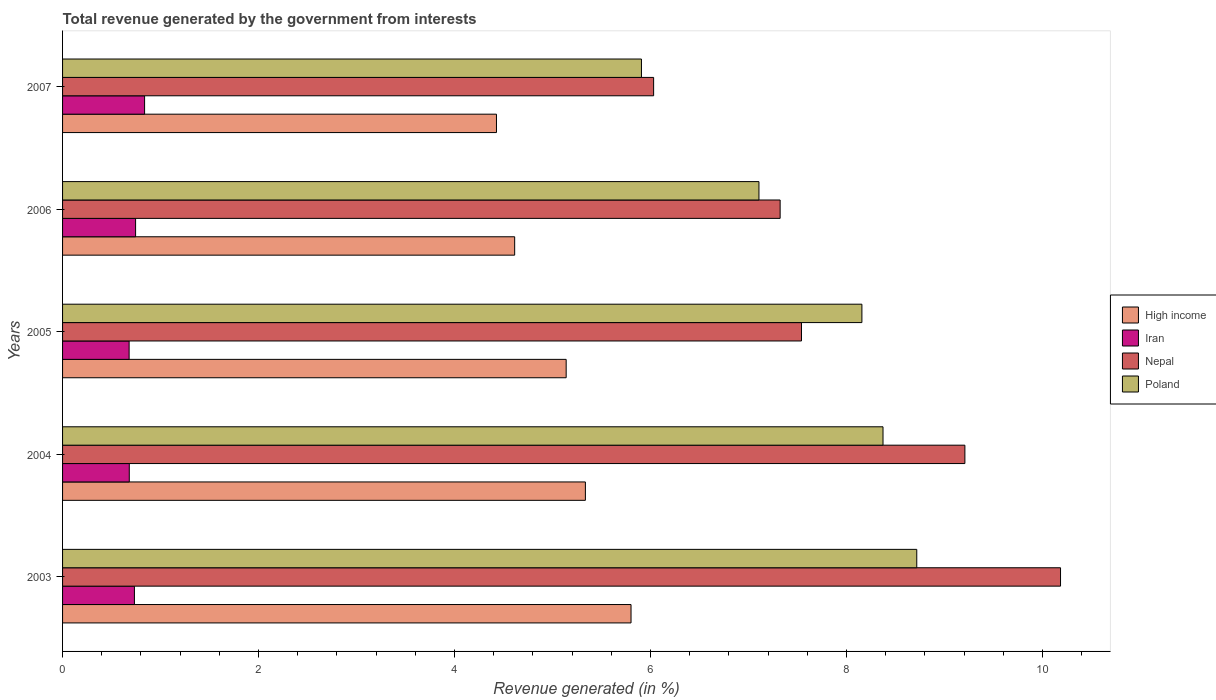How many different coloured bars are there?
Provide a succinct answer. 4. How many groups of bars are there?
Offer a very short reply. 5. Are the number of bars per tick equal to the number of legend labels?
Offer a very short reply. Yes. Are the number of bars on each tick of the Y-axis equal?
Your response must be concise. Yes. How many bars are there on the 3rd tick from the bottom?
Offer a terse response. 4. What is the label of the 4th group of bars from the top?
Offer a terse response. 2004. What is the total revenue generated in High income in 2005?
Your response must be concise. 5.14. Across all years, what is the maximum total revenue generated in Nepal?
Your response must be concise. 10.18. Across all years, what is the minimum total revenue generated in Nepal?
Provide a short and direct response. 6.03. What is the total total revenue generated in High income in the graph?
Make the answer very short. 25.32. What is the difference between the total revenue generated in Iran in 2003 and that in 2007?
Make the answer very short. -0.1. What is the difference between the total revenue generated in Nepal in 2007 and the total revenue generated in Iran in 2003?
Provide a short and direct response. 5.3. What is the average total revenue generated in High income per year?
Your response must be concise. 5.06. In the year 2005, what is the difference between the total revenue generated in Iran and total revenue generated in Poland?
Offer a terse response. -7.48. What is the ratio of the total revenue generated in Nepal in 2005 to that in 2006?
Your answer should be very brief. 1.03. Is the total revenue generated in Nepal in 2003 less than that in 2006?
Keep it short and to the point. No. Is the difference between the total revenue generated in Iran in 2005 and 2006 greater than the difference between the total revenue generated in Poland in 2005 and 2006?
Provide a succinct answer. No. What is the difference between the highest and the second highest total revenue generated in High income?
Keep it short and to the point. 0.47. What is the difference between the highest and the lowest total revenue generated in Nepal?
Keep it short and to the point. 4.15. Is the sum of the total revenue generated in Iran in 2004 and 2005 greater than the maximum total revenue generated in High income across all years?
Your response must be concise. No. What does the 4th bar from the top in 2005 represents?
Your answer should be very brief. High income. What does the 3rd bar from the bottom in 2007 represents?
Provide a succinct answer. Nepal. Is it the case that in every year, the sum of the total revenue generated in Poland and total revenue generated in Iran is greater than the total revenue generated in Nepal?
Offer a very short reply. No. How many bars are there?
Make the answer very short. 20. Are all the bars in the graph horizontal?
Provide a short and direct response. Yes. Does the graph contain grids?
Your answer should be compact. No. Where does the legend appear in the graph?
Make the answer very short. Center right. How are the legend labels stacked?
Ensure brevity in your answer.  Vertical. What is the title of the graph?
Provide a short and direct response. Total revenue generated by the government from interests. Does "Georgia" appear as one of the legend labels in the graph?
Offer a terse response. No. What is the label or title of the X-axis?
Provide a short and direct response. Revenue generated (in %). What is the Revenue generated (in %) of High income in 2003?
Your response must be concise. 5.8. What is the Revenue generated (in %) in Iran in 2003?
Provide a succinct answer. 0.73. What is the Revenue generated (in %) in Nepal in 2003?
Give a very brief answer. 10.18. What is the Revenue generated (in %) in Poland in 2003?
Make the answer very short. 8.72. What is the Revenue generated (in %) in High income in 2004?
Provide a succinct answer. 5.34. What is the Revenue generated (in %) of Iran in 2004?
Your answer should be compact. 0.68. What is the Revenue generated (in %) of Nepal in 2004?
Your response must be concise. 9.21. What is the Revenue generated (in %) in Poland in 2004?
Your response must be concise. 8.37. What is the Revenue generated (in %) of High income in 2005?
Give a very brief answer. 5.14. What is the Revenue generated (in %) of Iran in 2005?
Keep it short and to the point. 0.68. What is the Revenue generated (in %) of Nepal in 2005?
Provide a short and direct response. 7.54. What is the Revenue generated (in %) in Poland in 2005?
Ensure brevity in your answer.  8.16. What is the Revenue generated (in %) in High income in 2006?
Provide a succinct answer. 4.61. What is the Revenue generated (in %) in Iran in 2006?
Your answer should be compact. 0.75. What is the Revenue generated (in %) in Nepal in 2006?
Offer a very short reply. 7.32. What is the Revenue generated (in %) of Poland in 2006?
Your answer should be very brief. 7.11. What is the Revenue generated (in %) of High income in 2007?
Ensure brevity in your answer.  4.43. What is the Revenue generated (in %) in Iran in 2007?
Your answer should be compact. 0.84. What is the Revenue generated (in %) in Nepal in 2007?
Keep it short and to the point. 6.03. What is the Revenue generated (in %) in Poland in 2007?
Your answer should be compact. 5.91. Across all years, what is the maximum Revenue generated (in %) of High income?
Offer a terse response. 5.8. Across all years, what is the maximum Revenue generated (in %) of Iran?
Your answer should be compact. 0.84. Across all years, what is the maximum Revenue generated (in %) in Nepal?
Keep it short and to the point. 10.18. Across all years, what is the maximum Revenue generated (in %) in Poland?
Your answer should be compact. 8.72. Across all years, what is the minimum Revenue generated (in %) in High income?
Make the answer very short. 4.43. Across all years, what is the minimum Revenue generated (in %) of Iran?
Your answer should be compact. 0.68. Across all years, what is the minimum Revenue generated (in %) in Nepal?
Ensure brevity in your answer.  6.03. Across all years, what is the minimum Revenue generated (in %) in Poland?
Provide a succinct answer. 5.91. What is the total Revenue generated (in %) of High income in the graph?
Ensure brevity in your answer.  25.32. What is the total Revenue generated (in %) of Iran in the graph?
Your response must be concise. 3.68. What is the total Revenue generated (in %) in Nepal in the graph?
Keep it short and to the point. 40.29. What is the total Revenue generated (in %) in Poland in the graph?
Provide a succinct answer. 38.26. What is the difference between the Revenue generated (in %) in High income in 2003 and that in 2004?
Offer a very short reply. 0.47. What is the difference between the Revenue generated (in %) in Iran in 2003 and that in 2004?
Keep it short and to the point. 0.05. What is the difference between the Revenue generated (in %) in Nepal in 2003 and that in 2004?
Your response must be concise. 0.98. What is the difference between the Revenue generated (in %) in Poland in 2003 and that in 2004?
Make the answer very short. 0.34. What is the difference between the Revenue generated (in %) of High income in 2003 and that in 2005?
Provide a succinct answer. 0.66. What is the difference between the Revenue generated (in %) of Iran in 2003 and that in 2005?
Your answer should be compact. 0.05. What is the difference between the Revenue generated (in %) of Nepal in 2003 and that in 2005?
Keep it short and to the point. 2.64. What is the difference between the Revenue generated (in %) of Poland in 2003 and that in 2005?
Ensure brevity in your answer.  0.56. What is the difference between the Revenue generated (in %) in High income in 2003 and that in 2006?
Keep it short and to the point. 1.19. What is the difference between the Revenue generated (in %) of Iran in 2003 and that in 2006?
Offer a terse response. -0.01. What is the difference between the Revenue generated (in %) in Nepal in 2003 and that in 2006?
Give a very brief answer. 2.86. What is the difference between the Revenue generated (in %) of Poland in 2003 and that in 2006?
Offer a very short reply. 1.61. What is the difference between the Revenue generated (in %) in High income in 2003 and that in 2007?
Your response must be concise. 1.37. What is the difference between the Revenue generated (in %) of Iran in 2003 and that in 2007?
Offer a terse response. -0.1. What is the difference between the Revenue generated (in %) in Nepal in 2003 and that in 2007?
Give a very brief answer. 4.15. What is the difference between the Revenue generated (in %) in Poland in 2003 and that in 2007?
Offer a very short reply. 2.81. What is the difference between the Revenue generated (in %) in High income in 2004 and that in 2005?
Give a very brief answer. 0.2. What is the difference between the Revenue generated (in %) of Iran in 2004 and that in 2005?
Give a very brief answer. 0. What is the difference between the Revenue generated (in %) in Nepal in 2004 and that in 2005?
Your answer should be compact. 1.67. What is the difference between the Revenue generated (in %) of Poland in 2004 and that in 2005?
Keep it short and to the point. 0.22. What is the difference between the Revenue generated (in %) of High income in 2004 and that in 2006?
Your answer should be compact. 0.72. What is the difference between the Revenue generated (in %) in Iran in 2004 and that in 2006?
Give a very brief answer. -0.06. What is the difference between the Revenue generated (in %) of Nepal in 2004 and that in 2006?
Offer a very short reply. 1.89. What is the difference between the Revenue generated (in %) of Poland in 2004 and that in 2006?
Your answer should be very brief. 1.27. What is the difference between the Revenue generated (in %) in High income in 2004 and that in 2007?
Your response must be concise. 0.91. What is the difference between the Revenue generated (in %) of Iran in 2004 and that in 2007?
Your answer should be compact. -0.16. What is the difference between the Revenue generated (in %) in Nepal in 2004 and that in 2007?
Ensure brevity in your answer.  3.18. What is the difference between the Revenue generated (in %) in Poland in 2004 and that in 2007?
Your response must be concise. 2.47. What is the difference between the Revenue generated (in %) of High income in 2005 and that in 2006?
Give a very brief answer. 0.53. What is the difference between the Revenue generated (in %) of Iran in 2005 and that in 2006?
Your answer should be compact. -0.07. What is the difference between the Revenue generated (in %) of Nepal in 2005 and that in 2006?
Offer a terse response. 0.22. What is the difference between the Revenue generated (in %) in Poland in 2005 and that in 2006?
Make the answer very short. 1.05. What is the difference between the Revenue generated (in %) of High income in 2005 and that in 2007?
Make the answer very short. 0.71. What is the difference between the Revenue generated (in %) of Iran in 2005 and that in 2007?
Provide a succinct answer. -0.16. What is the difference between the Revenue generated (in %) in Nepal in 2005 and that in 2007?
Offer a very short reply. 1.51. What is the difference between the Revenue generated (in %) in Poland in 2005 and that in 2007?
Provide a succinct answer. 2.25. What is the difference between the Revenue generated (in %) of High income in 2006 and that in 2007?
Your response must be concise. 0.19. What is the difference between the Revenue generated (in %) in Iran in 2006 and that in 2007?
Offer a terse response. -0.09. What is the difference between the Revenue generated (in %) of Nepal in 2006 and that in 2007?
Provide a succinct answer. 1.29. What is the difference between the Revenue generated (in %) of Poland in 2006 and that in 2007?
Keep it short and to the point. 1.2. What is the difference between the Revenue generated (in %) in High income in 2003 and the Revenue generated (in %) in Iran in 2004?
Keep it short and to the point. 5.12. What is the difference between the Revenue generated (in %) in High income in 2003 and the Revenue generated (in %) in Nepal in 2004?
Provide a succinct answer. -3.41. What is the difference between the Revenue generated (in %) of High income in 2003 and the Revenue generated (in %) of Poland in 2004?
Provide a short and direct response. -2.57. What is the difference between the Revenue generated (in %) in Iran in 2003 and the Revenue generated (in %) in Nepal in 2004?
Provide a short and direct response. -8.48. What is the difference between the Revenue generated (in %) of Iran in 2003 and the Revenue generated (in %) of Poland in 2004?
Make the answer very short. -7.64. What is the difference between the Revenue generated (in %) of Nepal in 2003 and the Revenue generated (in %) of Poland in 2004?
Your answer should be very brief. 1.81. What is the difference between the Revenue generated (in %) of High income in 2003 and the Revenue generated (in %) of Iran in 2005?
Your answer should be compact. 5.12. What is the difference between the Revenue generated (in %) of High income in 2003 and the Revenue generated (in %) of Nepal in 2005?
Make the answer very short. -1.74. What is the difference between the Revenue generated (in %) in High income in 2003 and the Revenue generated (in %) in Poland in 2005?
Ensure brevity in your answer.  -2.36. What is the difference between the Revenue generated (in %) in Iran in 2003 and the Revenue generated (in %) in Nepal in 2005?
Offer a very short reply. -6.81. What is the difference between the Revenue generated (in %) of Iran in 2003 and the Revenue generated (in %) of Poland in 2005?
Your response must be concise. -7.42. What is the difference between the Revenue generated (in %) of Nepal in 2003 and the Revenue generated (in %) of Poland in 2005?
Provide a short and direct response. 2.03. What is the difference between the Revenue generated (in %) in High income in 2003 and the Revenue generated (in %) in Iran in 2006?
Ensure brevity in your answer.  5.06. What is the difference between the Revenue generated (in %) of High income in 2003 and the Revenue generated (in %) of Nepal in 2006?
Keep it short and to the point. -1.52. What is the difference between the Revenue generated (in %) in High income in 2003 and the Revenue generated (in %) in Poland in 2006?
Provide a succinct answer. -1.31. What is the difference between the Revenue generated (in %) in Iran in 2003 and the Revenue generated (in %) in Nepal in 2006?
Ensure brevity in your answer.  -6.59. What is the difference between the Revenue generated (in %) of Iran in 2003 and the Revenue generated (in %) of Poland in 2006?
Make the answer very short. -6.37. What is the difference between the Revenue generated (in %) in Nepal in 2003 and the Revenue generated (in %) in Poland in 2006?
Offer a terse response. 3.08. What is the difference between the Revenue generated (in %) in High income in 2003 and the Revenue generated (in %) in Iran in 2007?
Your answer should be compact. 4.96. What is the difference between the Revenue generated (in %) of High income in 2003 and the Revenue generated (in %) of Nepal in 2007?
Keep it short and to the point. -0.23. What is the difference between the Revenue generated (in %) in High income in 2003 and the Revenue generated (in %) in Poland in 2007?
Offer a terse response. -0.11. What is the difference between the Revenue generated (in %) of Iran in 2003 and the Revenue generated (in %) of Nepal in 2007?
Your answer should be very brief. -5.3. What is the difference between the Revenue generated (in %) in Iran in 2003 and the Revenue generated (in %) in Poland in 2007?
Ensure brevity in your answer.  -5.17. What is the difference between the Revenue generated (in %) of Nepal in 2003 and the Revenue generated (in %) of Poland in 2007?
Keep it short and to the point. 4.28. What is the difference between the Revenue generated (in %) of High income in 2004 and the Revenue generated (in %) of Iran in 2005?
Your answer should be compact. 4.66. What is the difference between the Revenue generated (in %) of High income in 2004 and the Revenue generated (in %) of Nepal in 2005?
Ensure brevity in your answer.  -2.21. What is the difference between the Revenue generated (in %) in High income in 2004 and the Revenue generated (in %) in Poland in 2005?
Your response must be concise. -2.82. What is the difference between the Revenue generated (in %) of Iran in 2004 and the Revenue generated (in %) of Nepal in 2005?
Your answer should be compact. -6.86. What is the difference between the Revenue generated (in %) in Iran in 2004 and the Revenue generated (in %) in Poland in 2005?
Give a very brief answer. -7.48. What is the difference between the Revenue generated (in %) of Nepal in 2004 and the Revenue generated (in %) of Poland in 2005?
Your answer should be very brief. 1.05. What is the difference between the Revenue generated (in %) of High income in 2004 and the Revenue generated (in %) of Iran in 2006?
Your answer should be compact. 4.59. What is the difference between the Revenue generated (in %) in High income in 2004 and the Revenue generated (in %) in Nepal in 2006?
Your response must be concise. -1.99. What is the difference between the Revenue generated (in %) of High income in 2004 and the Revenue generated (in %) of Poland in 2006?
Make the answer very short. -1.77. What is the difference between the Revenue generated (in %) of Iran in 2004 and the Revenue generated (in %) of Nepal in 2006?
Provide a succinct answer. -6.64. What is the difference between the Revenue generated (in %) of Iran in 2004 and the Revenue generated (in %) of Poland in 2006?
Ensure brevity in your answer.  -6.43. What is the difference between the Revenue generated (in %) of Nepal in 2004 and the Revenue generated (in %) of Poland in 2006?
Ensure brevity in your answer.  2.1. What is the difference between the Revenue generated (in %) of High income in 2004 and the Revenue generated (in %) of Iran in 2007?
Your answer should be very brief. 4.5. What is the difference between the Revenue generated (in %) in High income in 2004 and the Revenue generated (in %) in Nepal in 2007?
Provide a succinct answer. -0.7. What is the difference between the Revenue generated (in %) in High income in 2004 and the Revenue generated (in %) in Poland in 2007?
Keep it short and to the point. -0.57. What is the difference between the Revenue generated (in %) of Iran in 2004 and the Revenue generated (in %) of Nepal in 2007?
Your response must be concise. -5.35. What is the difference between the Revenue generated (in %) of Iran in 2004 and the Revenue generated (in %) of Poland in 2007?
Offer a terse response. -5.23. What is the difference between the Revenue generated (in %) of Nepal in 2004 and the Revenue generated (in %) of Poland in 2007?
Ensure brevity in your answer.  3.3. What is the difference between the Revenue generated (in %) in High income in 2005 and the Revenue generated (in %) in Iran in 2006?
Offer a terse response. 4.39. What is the difference between the Revenue generated (in %) in High income in 2005 and the Revenue generated (in %) in Nepal in 2006?
Make the answer very short. -2.18. What is the difference between the Revenue generated (in %) in High income in 2005 and the Revenue generated (in %) in Poland in 2006?
Make the answer very short. -1.97. What is the difference between the Revenue generated (in %) in Iran in 2005 and the Revenue generated (in %) in Nepal in 2006?
Keep it short and to the point. -6.64. What is the difference between the Revenue generated (in %) of Iran in 2005 and the Revenue generated (in %) of Poland in 2006?
Your answer should be very brief. -6.43. What is the difference between the Revenue generated (in %) of Nepal in 2005 and the Revenue generated (in %) of Poland in 2006?
Provide a short and direct response. 0.43. What is the difference between the Revenue generated (in %) in High income in 2005 and the Revenue generated (in %) in Iran in 2007?
Your answer should be compact. 4.3. What is the difference between the Revenue generated (in %) of High income in 2005 and the Revenue generated (in %) of Nepal in 2007?
Your response must be concise. -0.89. What is the difference between the Revenue generated (in %) in High income in 2005 and the Revenue generated (in %) in Poland in 2007?
Your answer should be compact. -0.77. What is the difference between the Revenue generated (in %) in Iran in 2005 and the Revenue generated (in %) in Nepal in 2007?
Make the answer very short. -5.35. What is the difference between the Revenue generated (in %) of Iran in 2005 and the Revenue generated (in %) of Poland in 2007?
Make the answer very short. -5.23. What is the difference between the Revenue generated (in %) in Nepal in 2005 and the Revenue generated (in %) in Poland in 2007?
Ensure brevity in your answer.  1.63. What is the difference between the Revenue generated (in %) in High income in 2006 and the Revenue generated (in %) in Iran in 2007?
Keep it short and to the point. 3.78. What is the difference between the Revenue generated (in %) in High income in 2006 and the Revenue generated (in %) in Nepal in 2007?
Your answer should be very brief. -1.42. What is the difference between the Revenue generated (in %) in High income in 2006 and the Revenue generated (in %) in Poland in 2007?
Your answer should be compact. -1.29. What is the difference between the Revenue generated (in %) in Iran in 2006 and the Revenue generated (in %) in Nepal in 2007?
Provide a short and direct response. -5.29. What is the difference between the Revenue generated (in %) in Iran in 2006 and the Revenue generated (in %) in Poland in 2007?
Offer a terse response. -5.16. What is the difference between the Revenue generated (in %) of Nepal in 2006 and the Revenue generated (in %) of Poland in 2007?
Provide a succinct answer. 1.42. What is the average Revenue generated (in %) of High income per year?
Keep it short and to the point. 5.06. What is the average Revenue generated (in %) in Iran per year?
Offer a terse response. 0.74. What is the average Revenue generated (in %) of Nepal per year?
Keep it short and to the point. 8.06. What is the average Revenue generated (in %) in Poland per year?
Ensure brevity in your answer.  7.65. In the year 2003, what is the difference between the Revenue generated (in %) in High income and Revenue generated (in %) in Iran?
Your answer should be compact. 5.07. In the year 2003, what is the difference between the Revenue generated (in %) in High income and Revenue generated (in %) in Nepal?
Make the answer very short. -4.38. In the year 2003, what is the difference between the Revenue generated (in %) in High income and Revenue generated (in %) in Poland?
Ensure brevity in your answer.  -2.92. In the year 2003, what is the difference between the Revenue generated (in %) in Iran and Revenue generated (in %) in Nepal?
Offer a very short reply. -9.45. In the year 2003, what is the difference between the Revenue generated (in %) of Iran and Revenue generated (in %) of Poland?
Keep it short and to the point. -7.98. In the year 2003, what is the difference between the Revenue generated (in %) of Nepal and Revenue generated (in %) of Poland?
Provide a short and direct response. 1.47. In the year 2004, what is the difference between the Revenue generated (in %) of High income and Revenue generated (in %) of Iran?
Your answer should be compact. 4.65. In the year 2004, what is the difference between the Revenue generated (in %) in High income and Revenue generated (in %) in Nepal?
Offer a terse response. -3.87. In the year 2004, what is the difference between the Revenue generated (in %) of High income and Revenue generated (in %) of Poland?
Offer a terse response. -3.04. In the year 2004, what is the difference between the Revenue generated (in %) in Iran and Revenue generated (in %) in Nepal?
Provide a short and direct response. -8.53. In the year 2004, what is the difference between the Revenue generated (in %) of Iran and Revenue generated (in %) of Poland?
Ensure brevity in your answer.  -7.69. In the year 2004, what is the difference between the Revenue generated (in %) of Nepal and Revenue generated (in %) of Poland?
Offer a terse response. 0.84. In the year 2005, what is the difference between the Revenue generated (in %) in High income and Revenue generated (in %) in Iran?
Your answer should be very brief. 4.46. In the year 2005, what is the difference between the Revenue generated (in %) of High income and Revenue generated (in %) of Nepal?
Your answer should be very brief. -2.4. In the year 2005, what is the difference between the Revenue generated (in %) in High income and Revenue generated (in %) in Poland?
Keep it short and to the point. -3.02. In the year 2005, what is the difference between the Revenue generated (in %) in Iran and Revenue generated (in %) in Nepal?
Keep it short and to the point. -6.86. In the year 2005, what is the difference between the Revenue generated (in %) in Iran and Revenue generated (in %) in Poland?
Your answer should be compact. -7.48. In the year 2005, what is the difference between the Revenue generated (in %) of Nepal and Revenue generated (in %) of Poland?
Your response must be concise. -0.62. In the year 2006, what is the difference between the Revenue generated (in %) of High income and Revenue generated (in %) of Iran?
Your answer should be compact. 3.87. In the year 2006, what is the difference between the Revenue generated (in %) of High income and Revenue generated (in %) of Nepal?
Keep it short and to the point. -2.71. In the year 2006, what is the difference between the Revenue generated (in %) in High income and Revenue generated (in %) in Poland?
Keep it short and to the point. -2.49. In the year 2006, what is the difference between the Revenue generated (in %) of Iran and Revenue generated (in %) of Nepal?
Your answer should be compact. -6.58. In the year 2006, what is the difference between the Revenue generated (in %) of Iran and Revenue generated (in %) of Poland?
Make the answer very short. -6.36. In the year 2006, what is the difference between the Revenue generated (in %) of Nepal and Revenue generated (in %) of Poland?
Provide a short and direct response. 0.22. In the year 2007, what is the difference between the Revenue generated (in %) in High income and Revenue generated (in %) in Iran?
Provide a short and direct response. 3.59. In the year 2007, what is the difference between the Revenue generated (in %) in High income and Revenue generated (in %) in Nepal?
Your answer should be compact. -1.6. In the year 2007, what is the difference between the Revenue generated (in %) in High income and Revenue generated (in %) in Poland?
Ensure brevity in your answer.  -1.48. In the year 2007, what is the difference between the Revenue generated (in %) in Iran and Revenue generated (in %) in Nepal?
Give a very brief answer. -5.19. In the year 2007, what is the difference between the Revenue generated (in %) of Iran and Revenue generated (in %) of Poland?
Your answer should be compact. -5.07. In the year 2007, what is the difference between the Revenue generated (in %) in Nepal and Revenue generated (in %) in Poland?
Keep it short and to the point. 0.12. What is the ratio of the Revenue generated (in %) of High income in 2003 to that in 2004?
Your answer should be very brief. 1.09. What is the ratio of the Revenue generated (in %) of Iran in 2003 to that in 2004?
Your answer should be compact. 1.08. What is the ratio of the Revenue generated (in %) in Nepal in 2003 to that in 2004?
Your response must be concise. 1.11. What is the ratio of the Revenue generated (in %) of Poland in 2003 to that in 2004?
Provide a succinct answer. 1.04. What is the ratio of the Revenue generated (in %) in High income in 2003 to that in 2005?
Your answer should be very brief. 1.13. What is the ratio of the Revenue generated (in %) of Iran in 2003 to that in 2005?
Provide a succinct answer. 1.08. What is the ratio of the Revenue generated (in %) of Nepal in 2003 to that in 2005?
Offer a very short reply. 1.35. What is the ratio of the Revenue generated (in %) of Poland in 2003 to that in 2005?
Keep it short and to the point. 1.07. What is the ratio of the Revenue generated (in %) in High income in 2003 to that in 2006?
Make the answer very short. 1.26. What is the ratio of the Revenue generated (in %) in Nepal in 2003 to that in 2006?
Provide a short and direct response. 1.39. What is the ratio of the Revenue generated (in %) of Poland in 2003 to that in 2006?
Provide a short and direct response. 1.23. What is the ratio of the Revenue generated (in %) of High income in 2003 to that in 2007?
Provide a short and direct response. 1.31. What is the ratio of the Revenue generated (in %) in Iran in 2003 to that in 2007?
Your answer should be very brief. 0.88. What is the ratio of the Revenue generated (in %) in Nepal in 2003 to that in 2007?
Your response must be concise. 1.69. What is the ratio of the Revenue generated (in %) in Poland in 2003 to that in 2007?
Provide a succinct answer. 1.48. What is the ratio of the Revenue generated (in %) in High income in 2004 to that in 2005?
Your answer should be very brief. 1.04. What is the ratio of the Revenue generated (in %) of Iran in 2004 to that in 2005?
Keep it short and to the point. 1. What is the ratio of the Revenue generated (in %) of Nepal in 2004 to that in 2005?
Give a very brief answer. 1.22. What is the ratio of the Revenue generated (in %) of Poland in 2004 to that in 2005?
Your answer should be compact. 1.03. What is the ratio of the Revenue generated (in %) of High income in 2004 to that in 2006?
Offer a terse response. 1.16. What is the ratio of the Revenue generated (in %) of Iran in 2004 to that in 2006?
Provide a succinct answer. 0.91. What is the ratio of the Revenue generated (in %) in Nepal in 2004 to that in 2006?
Make the answer very short. 1.26. What is the ratio of the Revenue generated (in %) of Poland in 2004 to that in 2006?
Your answer should be compact. 1.18. What is the ratio of the Revenue generated (in %) in High income in 2004 to that in 2007?
Your answer should be very brief. 1.2. What is the ratio of the Revenue generated (in %) of Iran in 2004 to that in 2007?
Offer a terse response. 0.81. What is the ratio of the Revenue generated (in %) in Nepal in 2004 to that in 2007?
Your answer should be very brief. 1.53. What is the ratio of the Revenue generated (in %) in Poland in 2004 to that in 2007?
Provide a short and direct response. 1.42. What is the ratio of the Revenue generated (in %) of High income in 2005 to that in 2006?
Give a very brief answer. 1.11. What is the ratio of the Revenue generated (in %) in Iran in 2005 to that in 2006?
Make the answer very short. 0.91. What is the ratio of the Revenue generated (in %) in Nepal in 2005 to that in 2006?
Make the answer very short. 1.03. What is the ratio of the Revenue generated (in %) of Poland in 2005 to that in 2006?
Provide a succinct answer. 1.15. What is the ratio of the Revenue generated (in %) of High income in 2005 to that in 2007?
Ensure brevity in your answer.  1.16. What is the ratio of the Revenue generated (in %) in Iran in 2005 to that in 2007?
Your answer should be compact. 0.81. What is the ratio of the Revenue generated (in %) in Nepal in 2005 to that in 2007?
Offer a terse response. 1.25. What is the ratio of the Revenue generated (in %) of Poland in 2005 to that in 2007?
Your answer should be compact. 1.38. What is the ratio of the Revenue generated (in %) of High income in 2006 to that in 2007?
Ensure brevity in your answer.  1.04. What is the ratio of the Revenue generated (in %) in Iran in 2006 to that in 2007?
Provide a short and direct response. 0.89. What is the ratio of the Revenue generated (in %) of Nepal in 2006 to that in 2007?
Provide a short and direct response. 1.21. What is the ratio of the Revenue generated (in %) of Poland in 2006 to that in 2007?
Your answer should be very brief. 1.2. What is the difference between the highest and the second highest Revenue generated (in %) of High income?
Provide a succinct answer. 0.47. What is the difference between the highest and the second highest Revenue generated (in %) in Iran?
Your answer should be very brief. 0.09. What is the difference between the highest and the second highest Revenue generated (in %) of Nepal?
Offer a terse response. 0.98. What is the difference between the highest and the second highest Revenue generated (in %) in Poland?
Give a very brief answer. 0.34. What is the difference between the highest and the lowest Revenue generated (in %) of High income?
Make the answer very short. 1.37. What is the difference between the highest and the lowest Revenue generated (in %) in Iran?
Make the answer very short. 0.16. What is the difference between the highest and the lowest Revenue generated (in %) in Nepal?
Make the answer very short. 4.15. What is the difference between the highest and the lowest Revenue generated (in %) in Poland?
Make the answer very short. 2.81. 